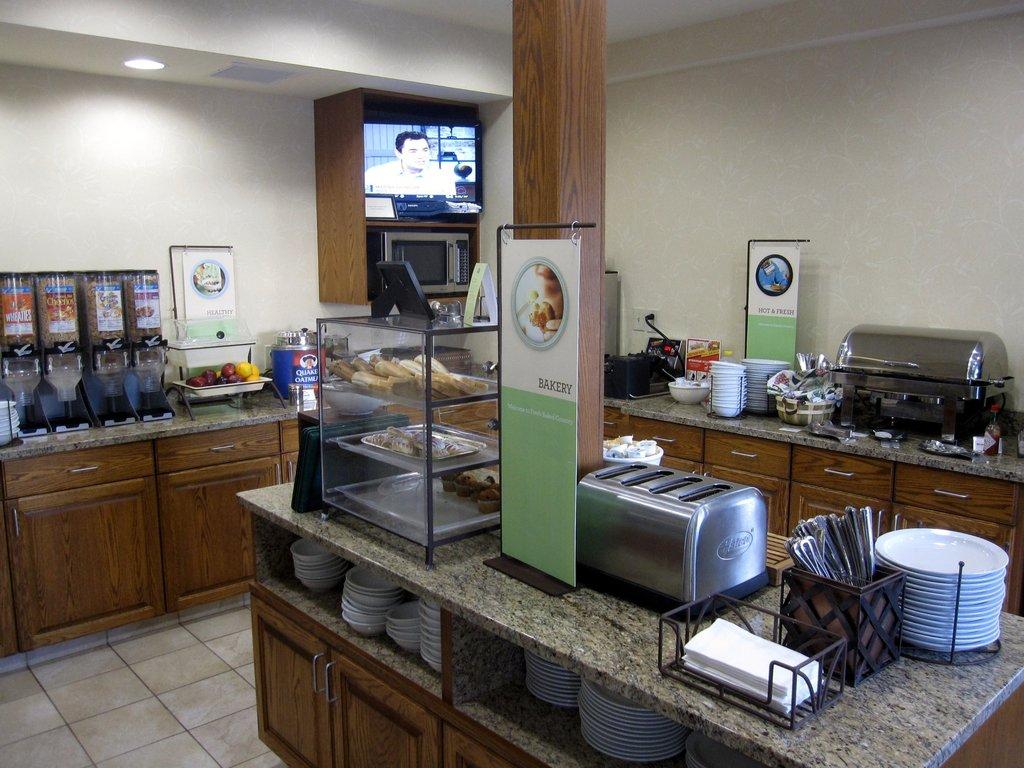What is the kitchen island section called?
Offer a very short reply. Bakery. 